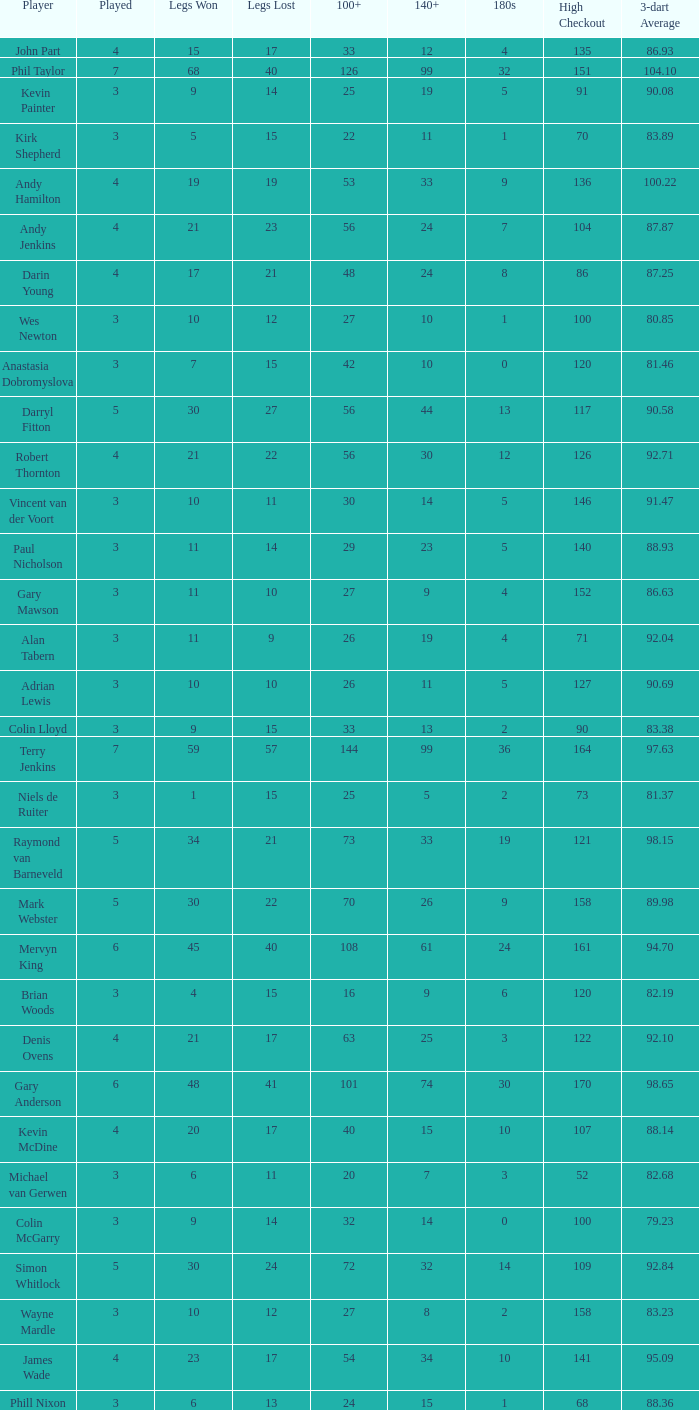What is the total number of 3-dart average when legs lost is larger than 41, and played is larger than 7? 0.0. 